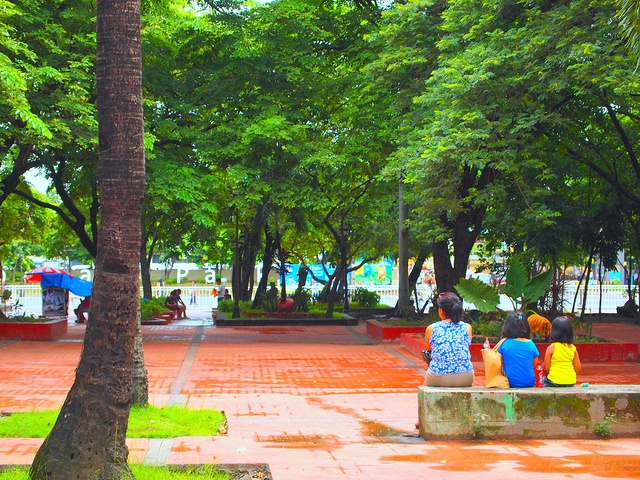Describe the objects in this image and their specific colors. I can see bench in lightgreen, tan, olive, and gray tones, people in lightgreen, white, and lightblue tones, people in lightgreen, blue, lightblue, gray, and black tones, people in lightgreen, yellow, black, red, and gray tones, and handbag in lightgreen, orange, tan, and khaki tones in this image. 